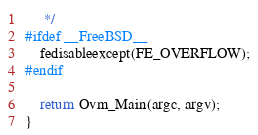Convert code to text. <code><loc_0><loc_0><loc_500><loc_500><_C_>	 */
#ifdef __FreeBSD__
	fedisableexcept(FE_OVERFLOW);
#endif

	return Ovm_Main(argc, argv);
}
</code> 